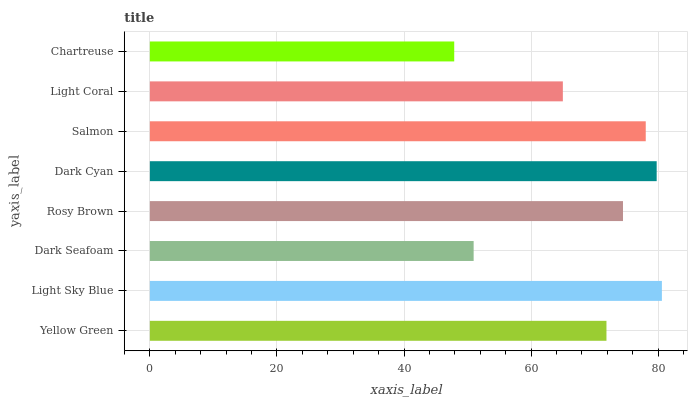Is Chartreuse the minimum?
Answer yes or no. Yes. Is Light Sky Blue the maximum?
Answer yes or no. Yes. Is Dark Seafoam the minimum?
Answer yes or no. No. Is Dark Seafoam the maximum?
Answer yes or no. No. Is Light Sky Blue greater than Dark Seafoam?
Answer yes or no. Yes. Is Dark Seafoam less than Light Sky Blue?
Answer yes or no. Yes. Is Dark Seafoam greater than Light Sky Blue?
Answer yes or no. No. Is Light Sky Blue less than Dark Seafoam?
Answer yes or no. No. Is Rosy Brown the high median?
Answer yes or no. Yes. Is Yellow Green the low median?
Answer yes or no. Yes. Is Light Sky Blue the high median?
Answer yes or no. No. Is Dark Seafoam the low median?
Answer yes or no. No. 